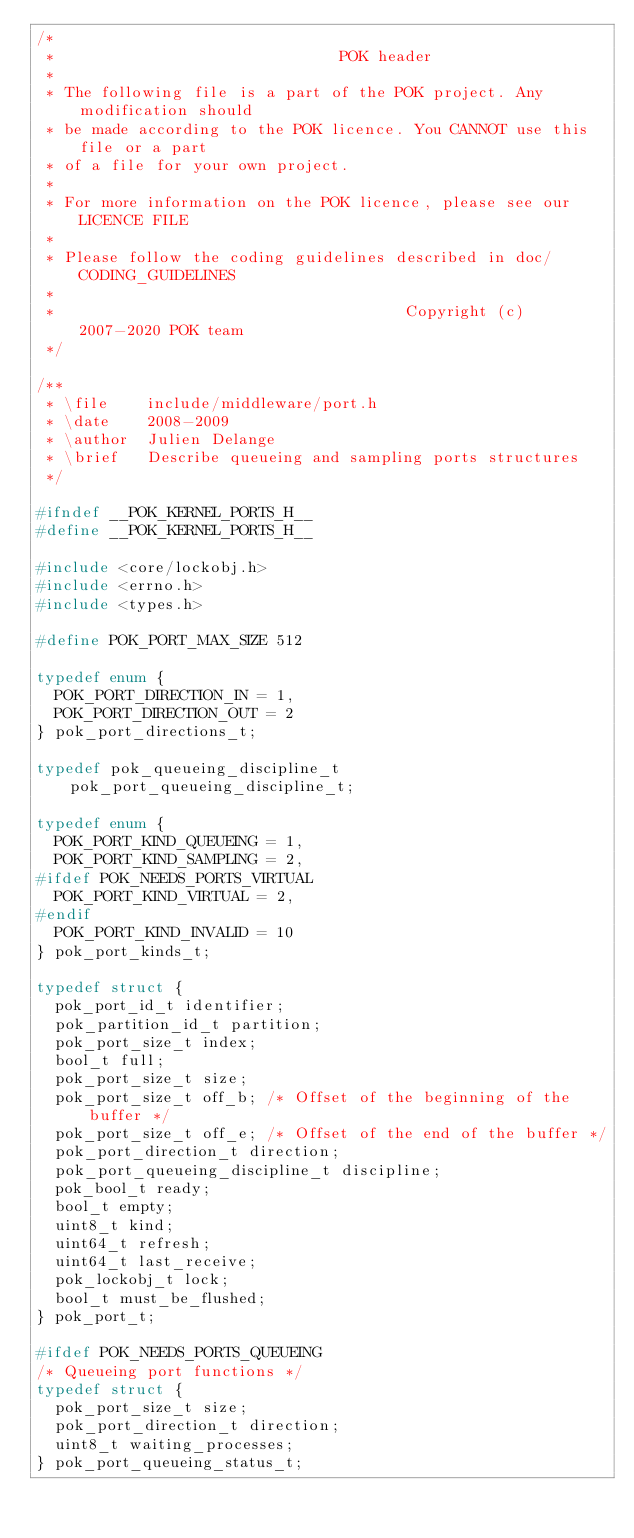Convert code to text. <code><loc_0><loc_0><loc_500><loc_500><_C_>/*
 *                               POK header
 *
 * The following file is a part of the POK project. Any modification should
 * be made according to the POK licence. You CANNOT use this file or a part
 * of a file for your own project.
 *
 * For more information on the POK licence, please see our LICENCE FILE
 *
 * Please follow the coding guidelines described in doc/CODING_GUIDELINES
 *
 *                                      Copyright (c) 2007-2020 POK team
 */

/**
 * \file    include/middleware/port.h
 * \date    2008-2009
 * \author  Julien Delange
 * \brief   Describe queueing and sampling ports structures
 */

#ifndef __POK_KERNEL_PORTS_H__
#define __POK_KERNEL_PORTS_H__

#include <core/lockobj.h>
#include <errno.h>
#include <types.h>

#define POK_PORT_MAX_SIZE 512

typedef enum {
  POK_PORT_DIRECTION_IN = 1,
  POK_PORT_DIRECTION_OUT = 2
} pok_port_directions_t;

typedef pok_queueing_discipline_t pok_port_queueing_discipline_t;

typedef enum {
  POK_PORT_KIND_QUEUEING = 1,
  POK_PORT_KIND_SAMPLING = 2,
#ifdef POK_NEEDS_PORTS_VIRTUAL
  POK_PORT_KIND_VIRTUAL = 2,
#endif
  POK_PORT_KIND_INVALID = 10
} pok_port_kinds_t;

typedef struct {
  pok_port_id_t identifier;
  pok_partition_id_t partition;
  pok_port_size_t index;
  bool_t full;
  pok_port_size_t size;
  pok_port_size_t off_b; /* Offset of the beginning of the buffer */
  pok_port_size_t off_e; /* Offset of the end of the buffer */
  pok_port_direction_t direction;
  pok_port_queueing_discipline_t discipline;
  pok_bool_t ready;
  bool_t empty;
  uint8_t kind;
  uint64_t refresh;
  uint64_t last_receive;
  pok_lockobj_t lock;
  bool_t must_be_flushed;
} pok_port_t;

#ifdef POK_NEEDS_PORTS_QUEUEING
/* Queueing port functions */
typedef struct {
  pok_port_size_t size;
  pok_port_direction_t direction;
  uint8_t waiting_processes;
} pok_port_queueing_status_t;
</code> 